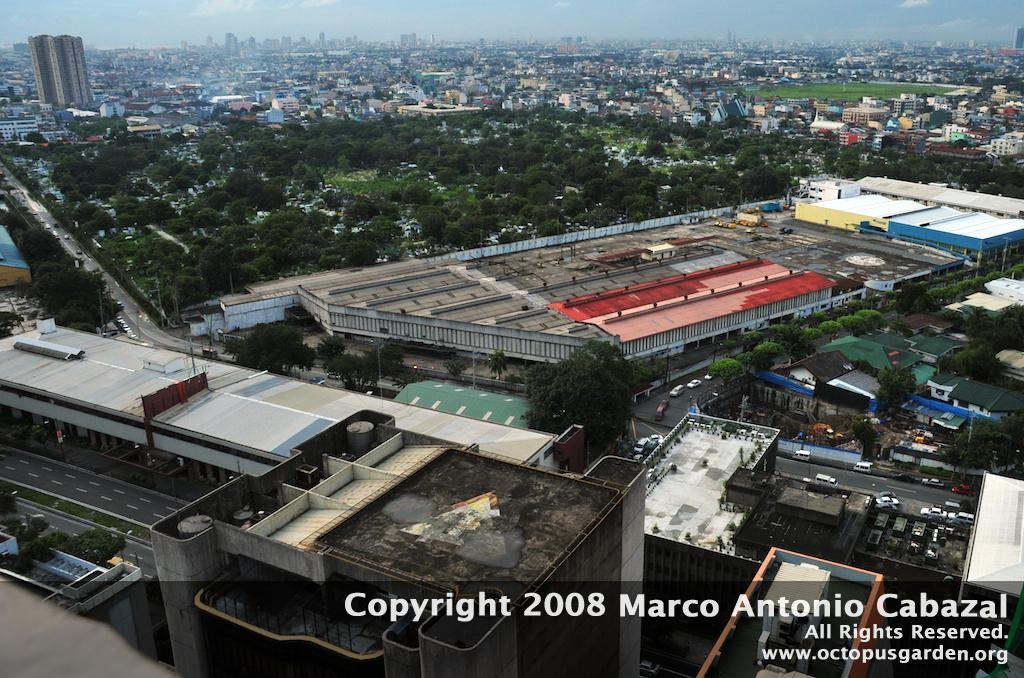What type of structures can be seen in the image? There are many buildings in the image. What other natural elements are present in the image? There are trees in the image. Is there any man-made infrastructure visible in the image? Yes, there is a road in the image. How was the image taken? The image is taken from a top view. What type of riddle is being solved by the moon in the image? There is no moon present in the image, and therefore no riddle being solved. 